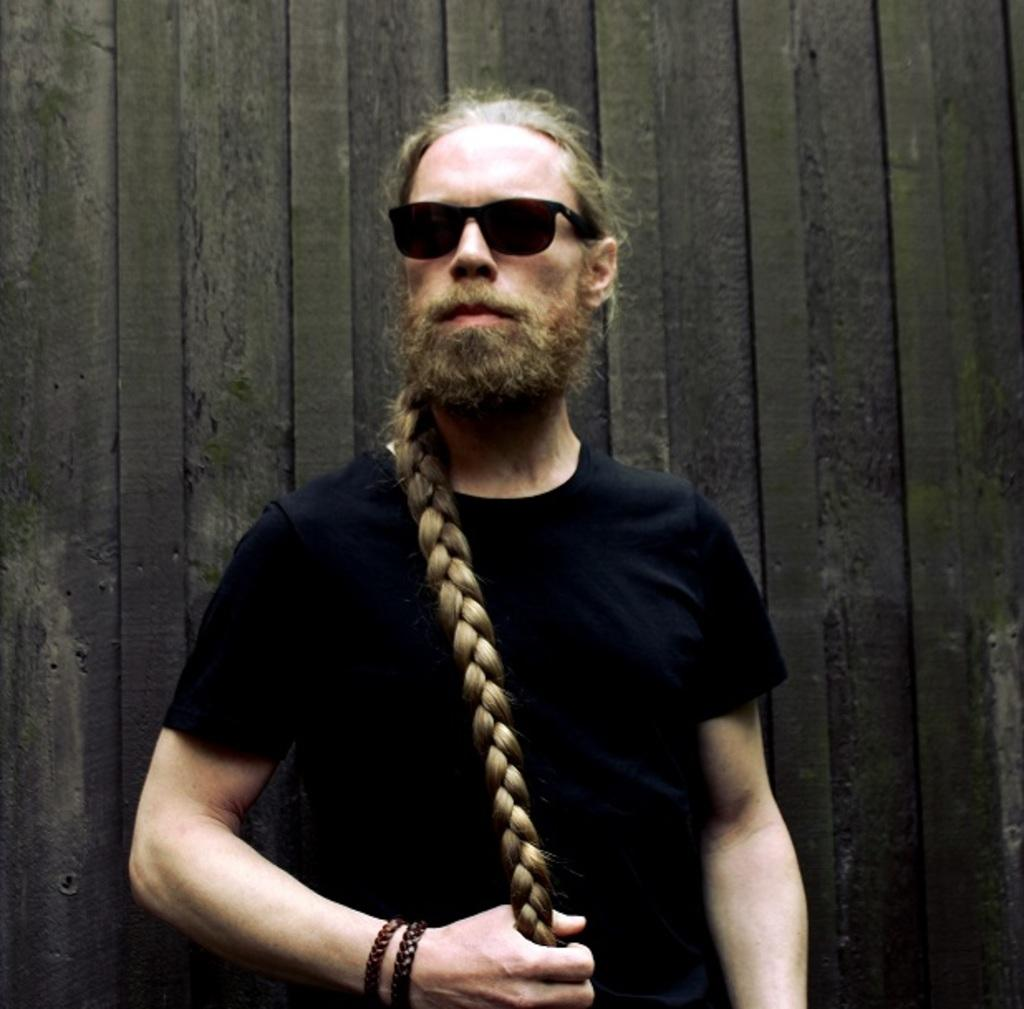Who is the main subject in the image? There is a man in the center of the image. What is the man doing in the image? The man is standing. What is the man wearing on his face? The man is wearing goggles. What can be seen in the background of the image? There is a wall in the background of the image. What type of trouble is the man experiencing in the image? There is no indication of trouble in the image; the man is simply standing and wearing goggles. 